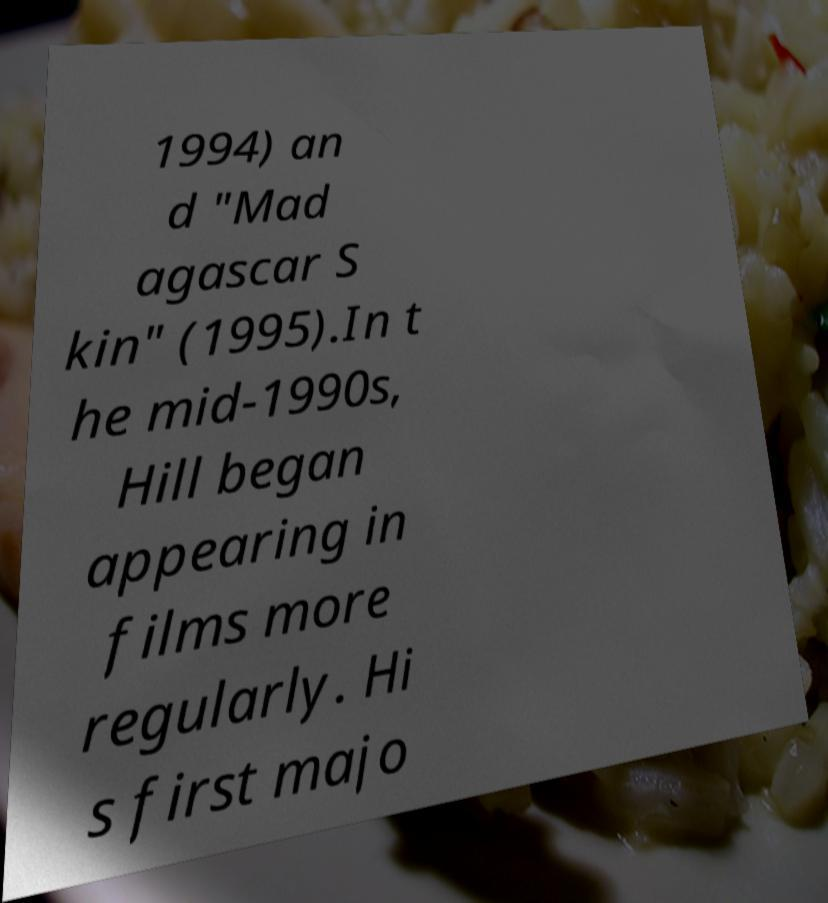There's text embedded in this image that I need extracted. Can you transcribe it verbatim? 1994) an d "Mad agascar S kin" (1995).In t he mid-1990s, Hill began appearing in films more regularly. Hi s first majo 